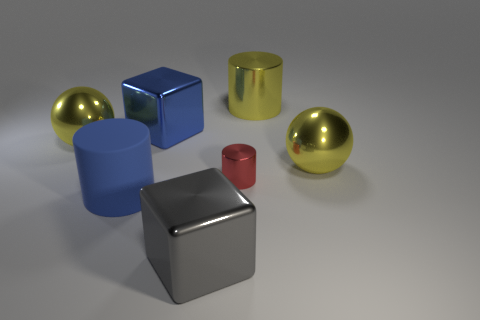There is a matte cylinder; is its color the same as the shiny cube behind the big blue matte thing? The matte cylinder has a distinct color that differs from the shiny cube behind the large blue object. While the cylinder is hued in a solid blue, the cube boasts a reflective metallic surface. Due to the distinct textures and lighting effects, the cube's color can look variable, sometimes mirroring its environment, which could make direct color comparison slightly challenging without closer observation. 